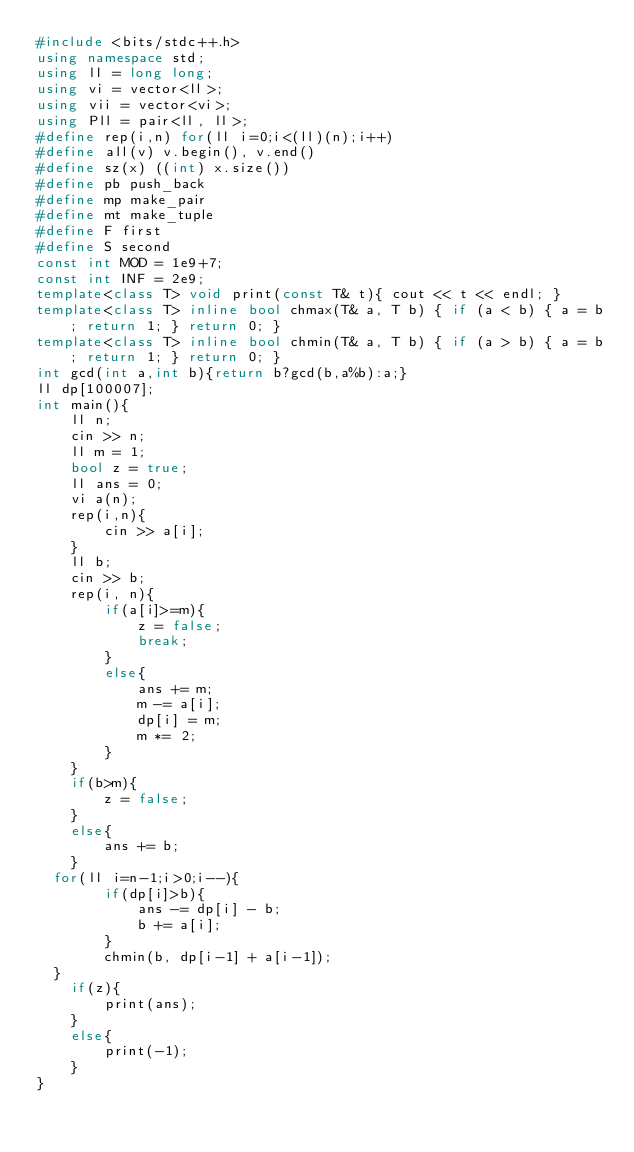<code> <loc_0><loc_0><loc_500><loc_500><_C++_>#include <bits/stdc++.h>
using namespace std;
using ll = long long;
using vi = vector<ll>;
using vii = vector<vi>;
using Pll = pair<ll, ll>;
#define rep(i,n) for(ll i=0;i<(ll)(n);i++)
#define all(v) v.begin(), v.end()
#define sz(x) ((int) x.size())
#define pb push_back
#define mp make_pair
#define mt make_tuple
#define F first
#define S second
const int MOD = 1e9+7;
const int INF = 2e9;
template<class T> void print(const T& t){ cout << t << endl; }
template<class T> inline bool chmax(T& a, T b) { if (a < b) { a = b; return 1; } return 0; }
template<class T> inline bool chmin(T& a, T b) { if (a > b) { a = b; return 1; } return 0; }
int gcd(int a,int b){return b?gcd(b,a%b):a;}
ll dp[100007];
int main(){
    ll n;
    cin >> n;
    ll m = 1;
    bool z = true;
    ll ans = 0;
    vi a(n);
    rep(i,n){
        cin >> a[i];
    }
    ll b;
    cin >> b;
    rep(i, n){
        if(a[i]>=m){
            z = false;
            break;
        }
        else{
            ans += m;
            m -= a[i];
            dp[i] = m;
            m *= 2;
        }
    }
    if(b>m){
        z = false;
    }
    else{
        ans += b;
    }
  for(ll i=n-1;i>0;i--){
        if(dp[i]>b){
            ans -= dp[i] - b;
            b += a[i];
        }
        chmin(b, dp[i-1] + a[i-1]);
  }
    if(z){
        print(ans);
    }
    else{
        print(-1);
    }
}
</code> 